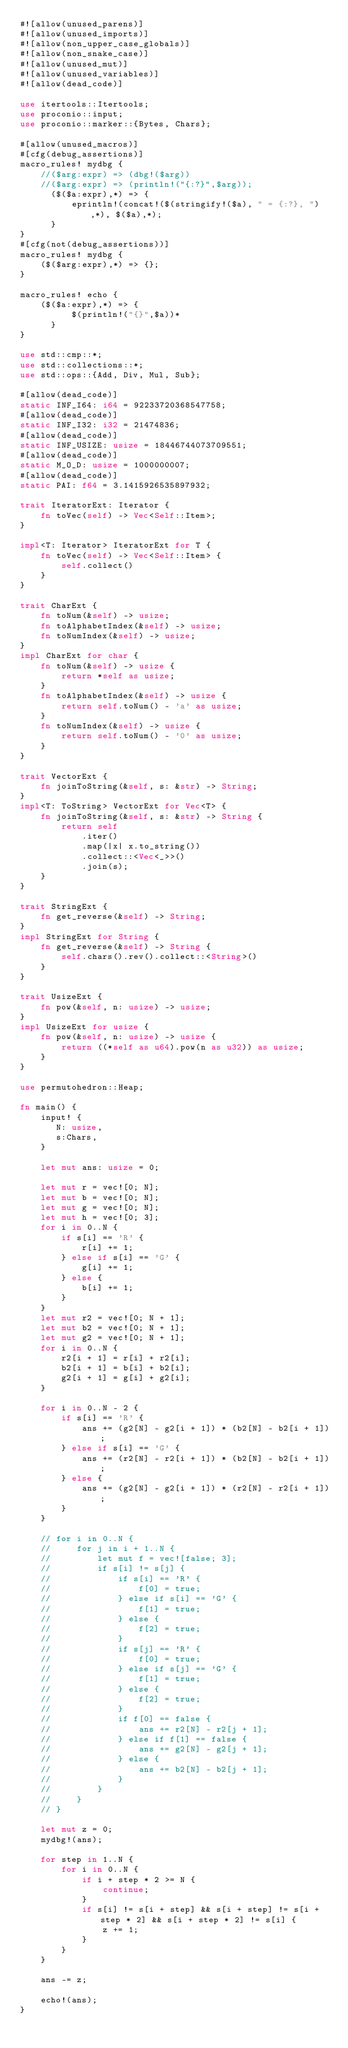Convert code to text. <code><loc_0><loc_0><loc_500><loc_500><_Rust_>#![allow(unused_parens)]
#![allow(unused_imports)]
#![allow(non_upper_case_globals)]
#![allow(non_snake_case)]
#![allow(unused_mut)]
#![allow(unused_variables)]
#![allow(dead_code)]

use itertools::Itertools;
use proconio::input;
use proconio::marker::{Bytes, Chars};

#[allow(unused_macros)]
#[cfg(debug_assertions)]
macro_rules! mydbg {
    //($arg:expr) => (dbg!($arg))
    //($arg:expr) => (println!("{:?}",$arg));
      ($($a:expr),*) => {
          eprintln!(concat!($(stringify!($a), " = {:?}, "),*), $($a),*);
      }
}
#[cfg(not(debug_assertions))]
macro_rules! mydbg {
    ($($arg:expr),*) => {};
}

macro_rules! echo {
    ($($a:expr),*) => {
          $(println!("{}",$a))*
      }
}

use std::cmp::*;
use std::collections::*;
use std::ops::{Add, Div, Mul, Sub};

#[allow(dead_code)]
static INF_I64: i64 = 92233720368547758;
#[allow(dead_code)]
static INF_I32: i32 = 21474836;
#[allow(dead_code)]
static INF_USIZE: usize = 18446744073709551;
#[allow(dead_code)]
static M_O_D: usize = 1000000007;
#[allow(dead_code)]
static PAI: f64 = 3.1415926535897932;

trait IteratorExt: Iterator {
    fn toVec(self) -> Vec<Self::Item>;
}

impl<T: Iterator> IteratorExt for T {
    fn toVec(self) -> Vec<Self::Item> {
        self.collect()
    }
}

trait CharExt {
    fn toNum(&self) -> usize;
    fn toAlphabetIndex(&self) -> usize;
    fn toNumIndex(&self) -> usize;
}
impl CharExt for char {
    fn toNum(&self) -> usize {
        return *self as usize;
    }
    fn toAlphabetIndex(&self) -> usize {
        return self.toNum() - 'a' as usize;
    }
    fn toNumIndex(&self) -> usize {
        return self.toNum() - '0' as usize;
    }
}

trait VectorExt {
    fn joinToString(&self, s: &str) -> String;
}
impl<T: ToString> VectorExt for Vec<T> {
    fn joinToString(&self, s: &str) -> String {
        return self
            .iter()
            .map(|x| x.to_string())
            .collect::<Vec<_>>()
            .join(s);
    }
}

trait StringExt {
    fn get_reverse(&self) -> String;
}
impl StringExt for String {
    fn get_reverse(&self) -> String {
        self.chars().rev().collect::<String>()
    }
}

trait UsizeExt {
    fn pow(&self, n: usize) -> usize;
}
impl UsizeExt for usize {
    fn pow(&self, n: usize) -> usize {
        return ((*self as u64).pow(n as u32)) as usize;
    }
}

use permutohedron::Heap;

fn main() {
    input! {
       N: usize,
       s:Chars,
    }

    let mut ans: usize = 0;

    let mut r = vec![0; N];
    let mut b = vec![0; N];
    let mut g = vec![0; N];
    let mut h = vec![0; 3];
    for i in 0..N {
        if s[i] == 'R' {
            r[i] += 1;
        } else if s[i] == 'G' {
            g[i] += 1;
        } else {
            b[i] += 1;
        }
    }
    let mut r2 = vec![0; N + 1];
    let mut b2 = vec![0; N + 1];
    let mut g2 = vec![0; N + 1];
    for i in 0..N {
        r2[i + 1] = r[i] + r2[i];
        b2[i + 1] = b[i] + b2[i];
        g2[i + 1] = g[i] + g2[i];
    }

    for i in 0..N - 2 {
        if s[i] == 'R' {
            ans += (g2[N] - g2[i + 1]) * (b2[N] - b2[i + 1]);
        } else if s[i] == 'G' {
            ans += (r2[N] - r2[i + 1]) * (b2[N] - b2[i + 1]);
        } else {
            ans += (g2[N] - g2[i + 1]) * (r2[N] - r2[i + 1]);
        }
    }

    // for i in 0..N {
    //     for j in i + 1..N {
    //         let mut f = vec![false; 3];
    //         if s[i] != s[j] {
    //             if s[i] == 'R' {
    //                 f[0] = true;
    //             } else if s[i] == 'G' {
    //                 f[1] = true;
    //             } else {
    //                 f[2] = true;
    //             }
    //             if s[j] == 'R' {
    //                 f[0] = true;
    //             } else if s[j] == 'G' {
    //                 f[1] = true;
    //             } else {
    //                 f[2] = true;
    //             }
    //             if f[0] == false {
    //                 ans += r2[N] - r2[j + 1];
    //             } else if f[1] == false {
    //                 ans += g2[N] - g2[j + 1];
    //             } else {
    //                 ans += b2[N] - b2[j + 1];
    //             }
    //         }
    //     }
    // }

    let mut z = 0;
    mydbg!(ans);

    for step in 1..N {
        for i in 0..N {
            if i + step * 2 >= N {
                continue;
            }
            if s[i] != s[i + step] && s[i + step] != s[i + step * 2] && s[i + step * 2] != s[i] {
                z += 1;
            }
        }
    }

    ans -= z;

    echo!(ans);
}
</code> 